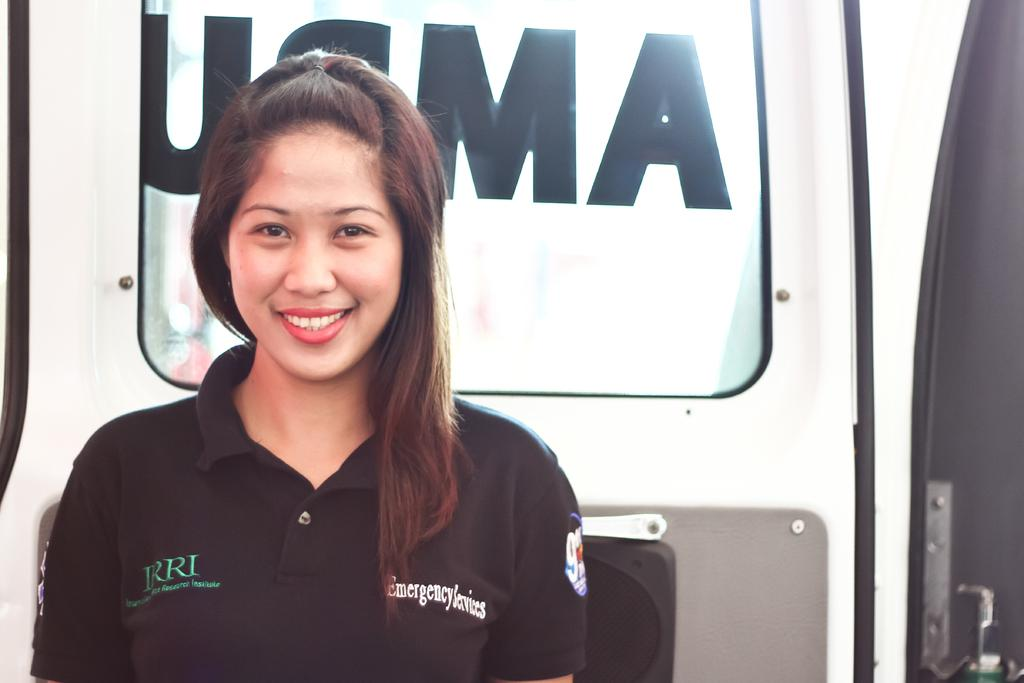Who is present in the image? There is a woman in the image. What is the woman doing in the image? The woman is standing and smiling. What can be seen behind the woman in the image? There is a vehicle behind the woman. What type of feast is the woman preparing in the image? There is no indication in the image that the woman is preparing a feast, as she is simply standing and smiling. Can you see a rake in the image? There is no rake present in the image. 